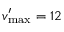Convert formula to latex. <formula><loc_0><loc_0><loc_500><loc_500>v _ { \max } ^ { \prime } = 1 2</formula> 